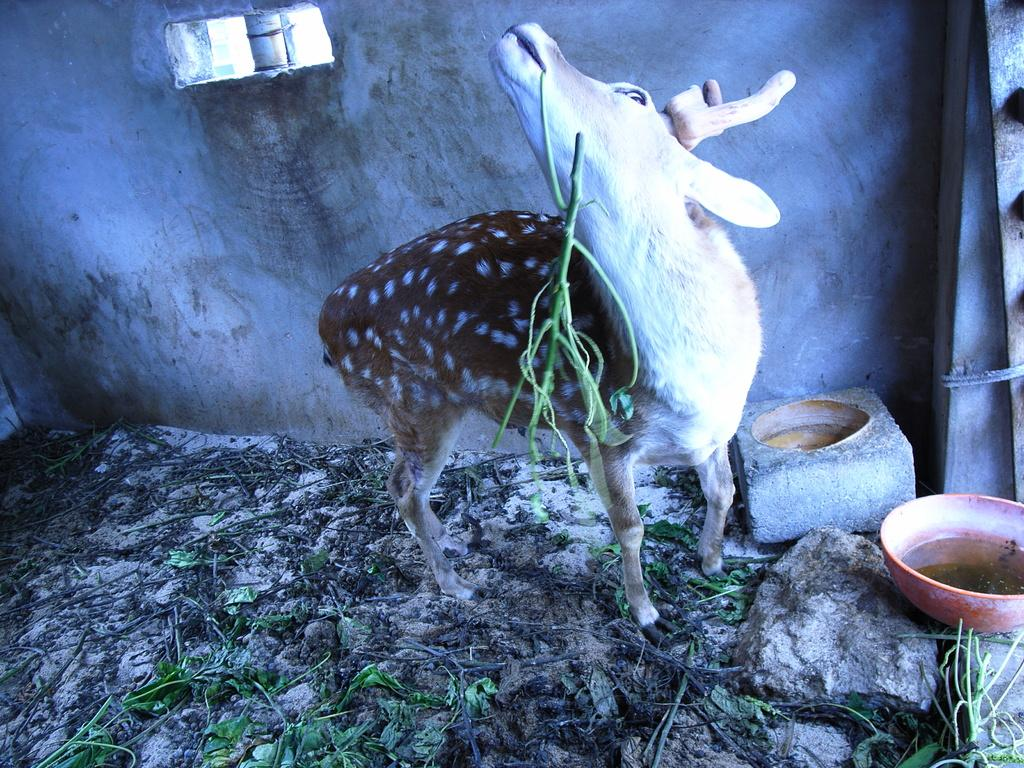What type of animal is in the image? There is an animal in the image, but the specific type cannot be determined from the provided facts. What natural elements are present in the image? There are leaves, stones, and stems visible in the image. What is the purpose of the bowl in the image? The purpose of the bowl cannot be determined from the provided facts. Is there any liquid visible in the image? Yes, there is water visible in the image. What can be seen in the background of the image? There is a wall visible in the background of the image. How many kittens are sitting on the tin in the image? There is no tin or kittens present in the image. What type of education is being provided in the image? There is no indication of any educational activity in the image. 